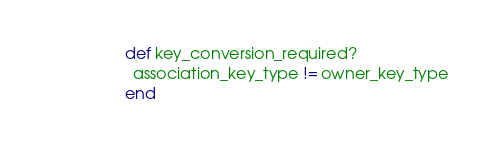<code> <loc_0><loc_0><loc_500><loc_500><_Ruby_>        def key_conversion_required?
          association_key_type != owner_key_type
        end
</code> 